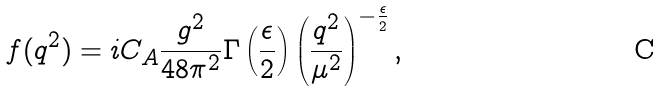Convert formula to latex. <formula><loc_0><loc_0><loc_500><loc_500>f ( q ^ { 2 } ) = i C _ { A } \frac { g ^ { 2 } } { 4 8 \pi ^ { 2 } } \Gamma \left ( \frac { \epsilon } { 2 } \right ) \left ( \frac { q ^ { 2 } } { \mu ^ { 2 } } \right ) ^ { - \frac { \epsilon } { 2 } } ,</formula> 